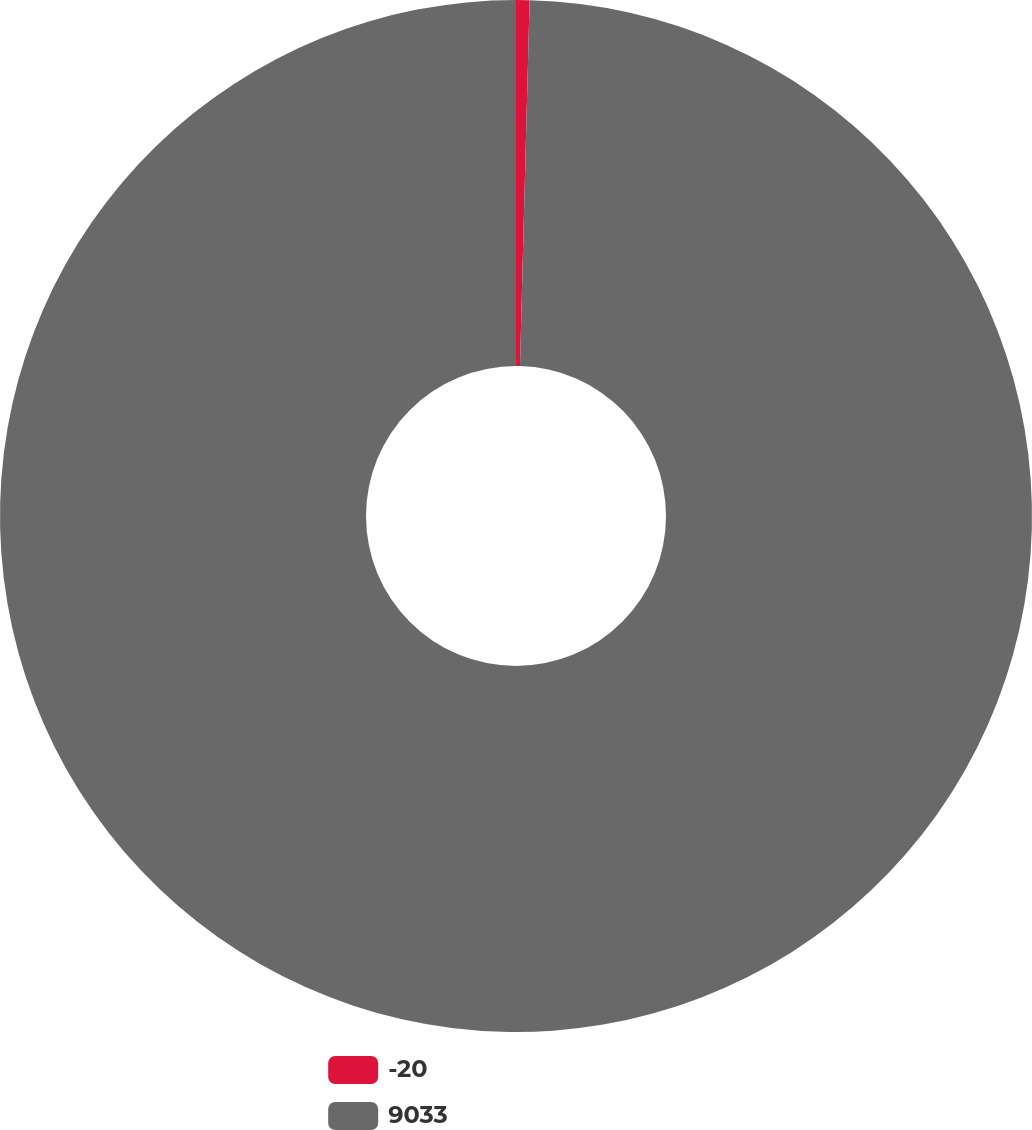Convert chart to OTSL. <chart><loc_0><loc_0><loc_500><loc_500><pie_chart><fcel>-20<fcel>9033<nl><fcel>0.42%<fcel>99.58%<nl></chart> 